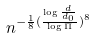Convert formula to latex. <formula><loc_0><loc_0><loc_500><loc_500>n ^ { - \frac { 1 } { 8 } ( \frac { \log \frac { d } { d _ { 0 } } } { \log \Pi } ) ^ { 8 } }</formula> 